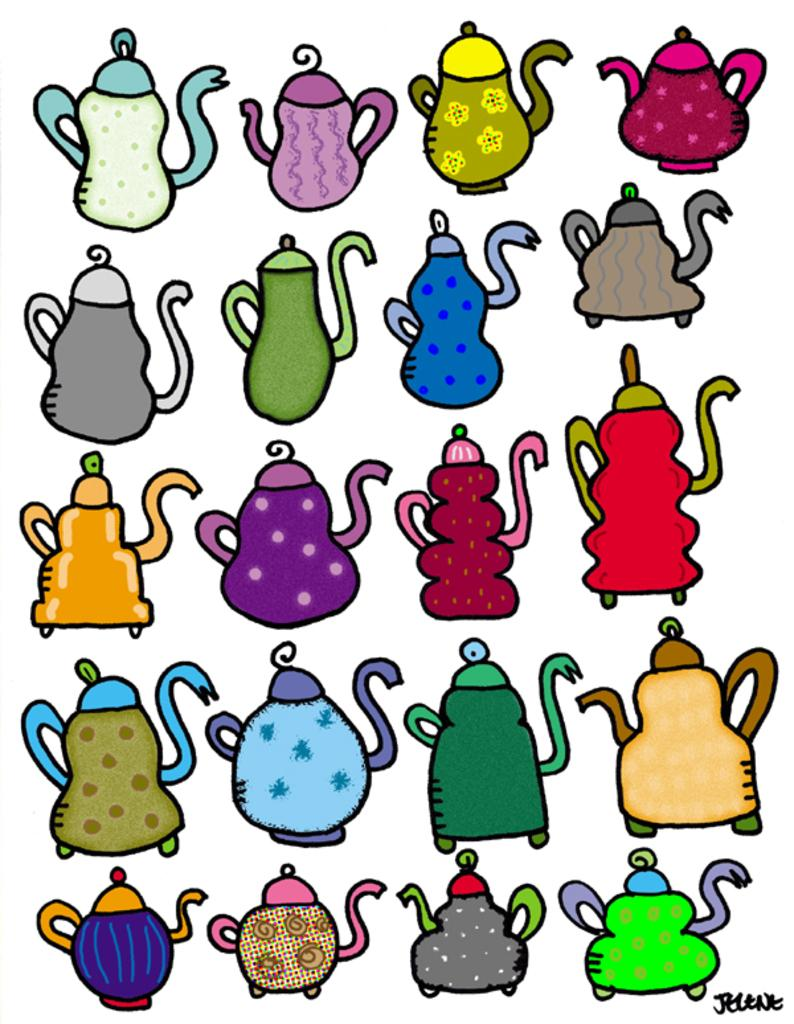What type of image is being described? The image is animated. What objects can be seen in the image? There are jugs in different colors in the image. What color is the background of the image? The background of the image is white. How many hens are present in the image? There are no hens present in the image; it features jugs in different colors against a white background. 